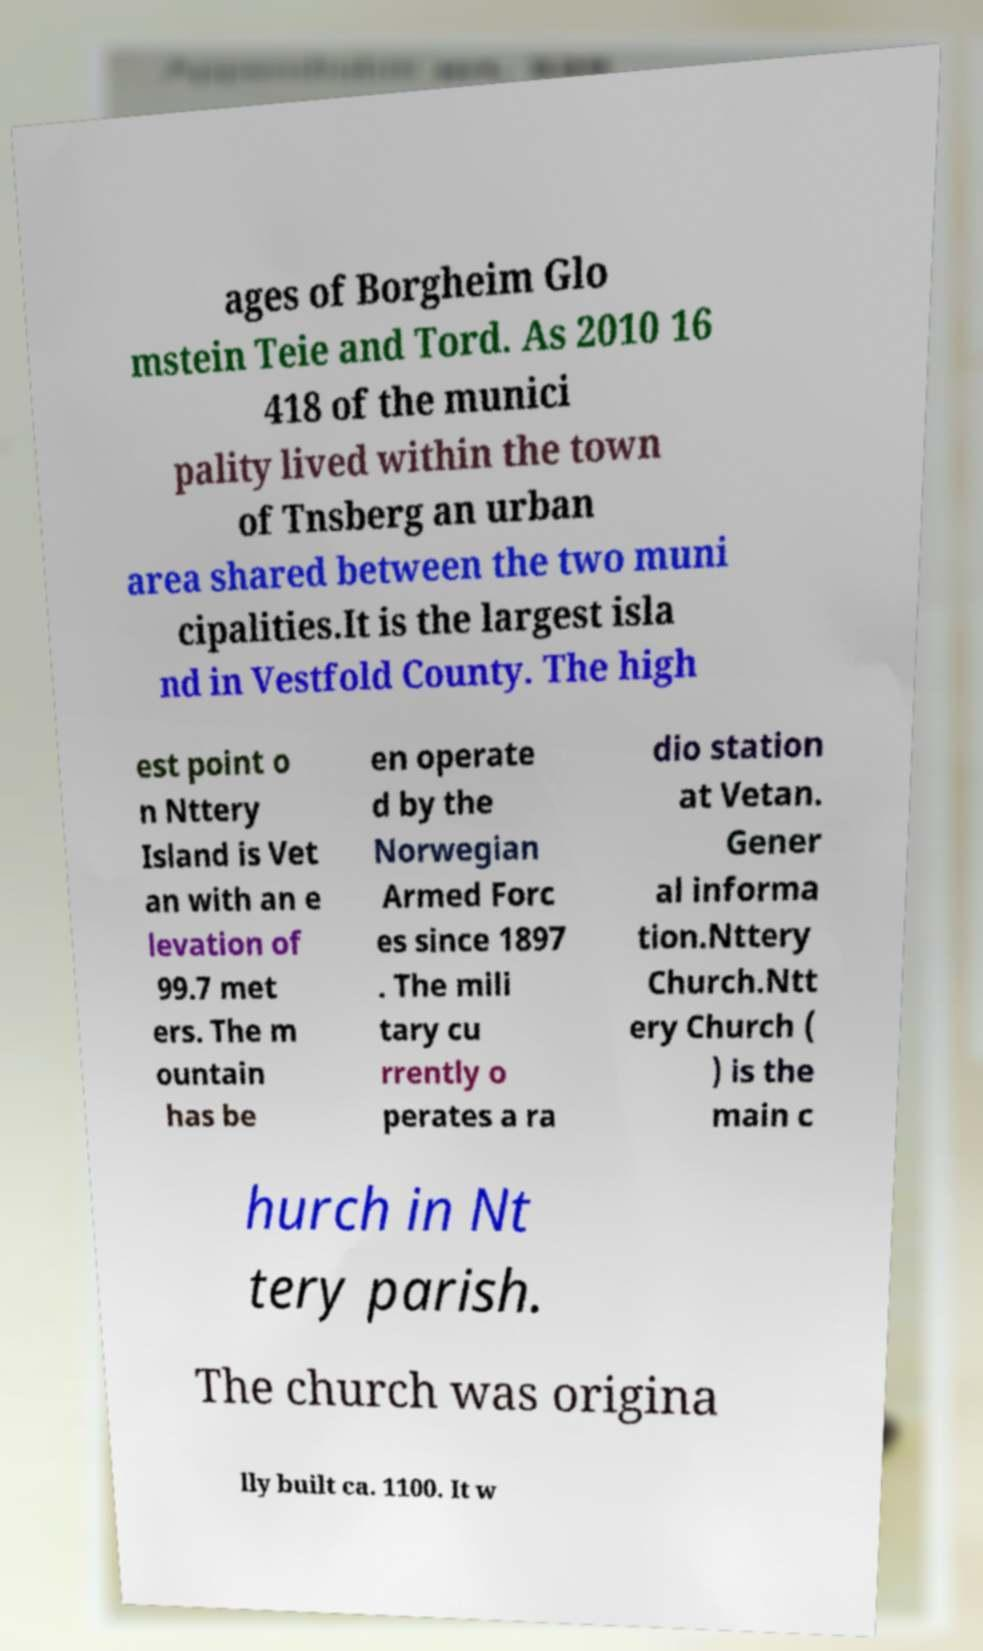Please identify and transcribe the text found in this image. ages of Borgheim Glo mstein Teie and Tord. As 2010 16 418 of the munici pality lived within the town of Tnsberg an urban area shared between the two muni cipalities.It is the largest isla nd in Vestfold County. The high est point o n Nttery Island is Vet an with an e levation of 99.7 met ers. The m ountain has be en operate d by the Norwegian Armed Forc es since 1897 . The mili tary cu rrently o perates a ra dio station at Vetan. Gener al informa tion.Nttery Church.Ntt ery Church ( ) is the main c hurch in Nt tery parish. The church was origina lly built ca. 1100. It w 